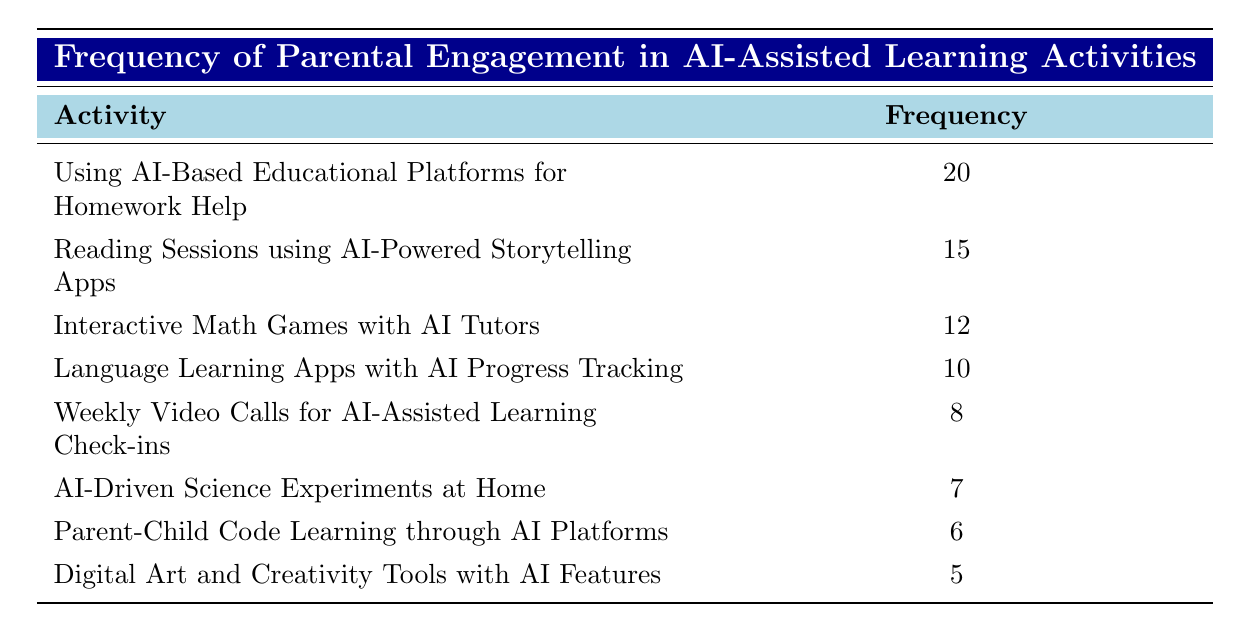What is the frequency of "Using AI-Based Educational Platforms for Homework Help"? The table lists the frequency of parental engagement for various activities. The frequency associated with "Using AI-Based Educational Platforms for Homework Help" is 20.
Answer: 20 What is the activity with the lowest frequency of parental engagement? By comparing the frequencies listed in the table, the lowest frequency is associated with "Digital Art and Creativity Tools with AI Features," which has a frequency of 5.
Answer: Digital Art and Creativity Tools with AI Features How many total activities are listed in the table? The table lists eight different activities related to parental engagement, which can be counted directly from the rows under the activity column.
Answer: 8 What is the average frequency of parental engagement across all activities? To find the average, sum the frequencies (20 + 15 + 12 + 10 + 8 + 7 + 6 + 5 = 73) and divide by the total number of activities (73 / 8 = 9.125). The average frequency is therefore approximately 9.125.
Answer: 9.125 Is "Interactive Math Games with AI Tutors" more frequently engaged than "AI-Driven Science Experiments at Home"? The frequency of "Interactive Math Games with AI Tutors" is 12, while "AI-Driven Science Experiments at Home" has a frequency of 7. Since 12 is greater than 7, the statement is true.
Answer: Yes How much more frequently do parents engage in "Using AI-Based Educational Platforms for Homework Help" compared to "Parent-Child Code Learning through AI Platforms"? The frequency for "Using AI-Based Educational Platforms for Homework Help" is 20 and for "Parent-Child Code Learning through AI Platforms" it is 6. The difference is 20 - 6 = 14.
Answer: 14 True or False: The total frequency of reading and language activities exceeds 25. The frequency for reading sessions is 15 and for language learning apps is 10. Adding these gives 15 + 10 = 25, which does not exceed 25, so the statement is false.
Answer: False What percentage of the total parental engagement frequency is attributed to "Weekly Video Calls for AI-Assisted Learning Check-ins"? The frequency of "Weekly Video Calls for AI-Assisted Learning Check-ins" is 8. The total frequency is 73 (as calculated before). To find the percentage: (8 / 73) * 100 ≈ 10.96%.
Answer: 10.96% 